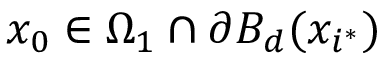<formula> <loc_0><loc_0><loc_500><loc_500>x _ { 0 } \in \Omega _ { 1 } \cap \partial B _ { d } ( x _ { i ^ { \ast } } )</formula> 